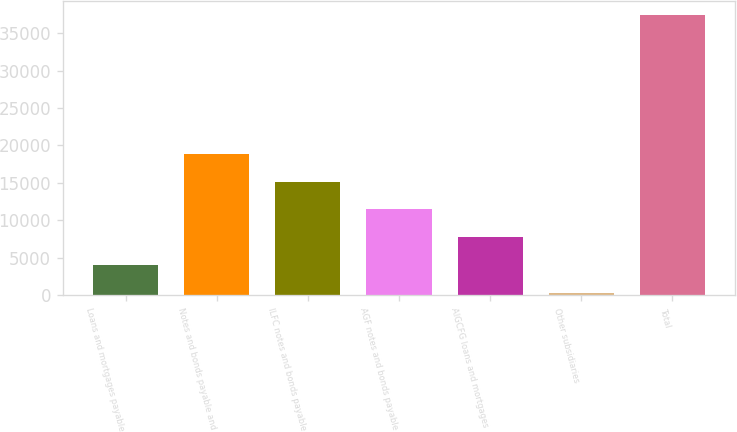<chart> <loc_0><loc_0><loc_500><loc_500><bar_chart><fcel>Loans and mortgages payable<fcel>Notes and bonds payable and<fcel>ILFC notes and bonds payable<fcel>AGF notes and bonds payable<fcel>AIGCFG loans and mortgages<fcel>Other subsidiaries<fcel>Total<nl><fcel>4050.4<fcel>18852<fcel>15151.6<fcel>11451.2<fcel>7750.8<fcel>350<fcel>37354<nl></chart> 